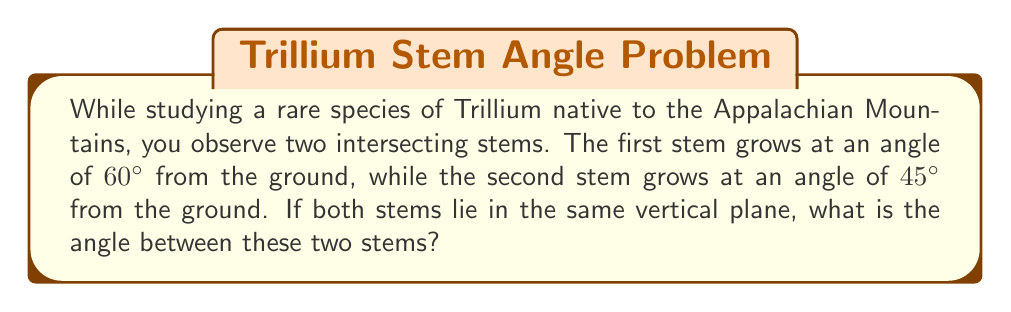Help me with this question. To solve this problem, we'll use the concept of angles between lines in 3D space. Since both stems lie in the same vertical plane, we can treat this as a 2D problem.

Step 1: Visualize the problem
[asy]
import geometry;

size(200);
draw((0,0)--(3,0), arrow=Arrow);
draw((0,0)--(0,3), arrow=Arrow);
draw((0,0)--(3,sqrt(3)), arrow=Arrow);
draw((0,0)--(3,3), arrow=Arrow);

label("Ground", (1.5,0), S);
label("Vertical", (0,1.5), W);
label("Stem 1", (1.5,0.866), NE);
label("Stem 2", (1.5,1.5), NE);

draw((2.8,0)--arc((0,0),2.8,0,60));
draw((2.8,0)--arc((0,0),2.8,0,45));

label("60°", (1.2,0.3), NE);
label("45°", (1,0.5), NW);
label("θ", (0.5,0.9), SE);
[/asy]

Step 2: Understand the given information
- Stem 1 makes an angle of 60° with the ground
- Stem 2 makes an angle of 45° with the ground

Step 3: Calculate the angle between the stems
The angle between the stems (θ) is the absolute difference between their angles from the ground:

$$\theta = |60° - 45°| = 15°$$

Step 4: Verify the result
We can check if this makes sense:
- If the stems were at the same angle, θ would be 0°
- If one stem was vertical (90°) and the other horizontal (0°), θ would be 90°
Our result of 15° falls within this range and matches the visual representation.
Answer: 15° 